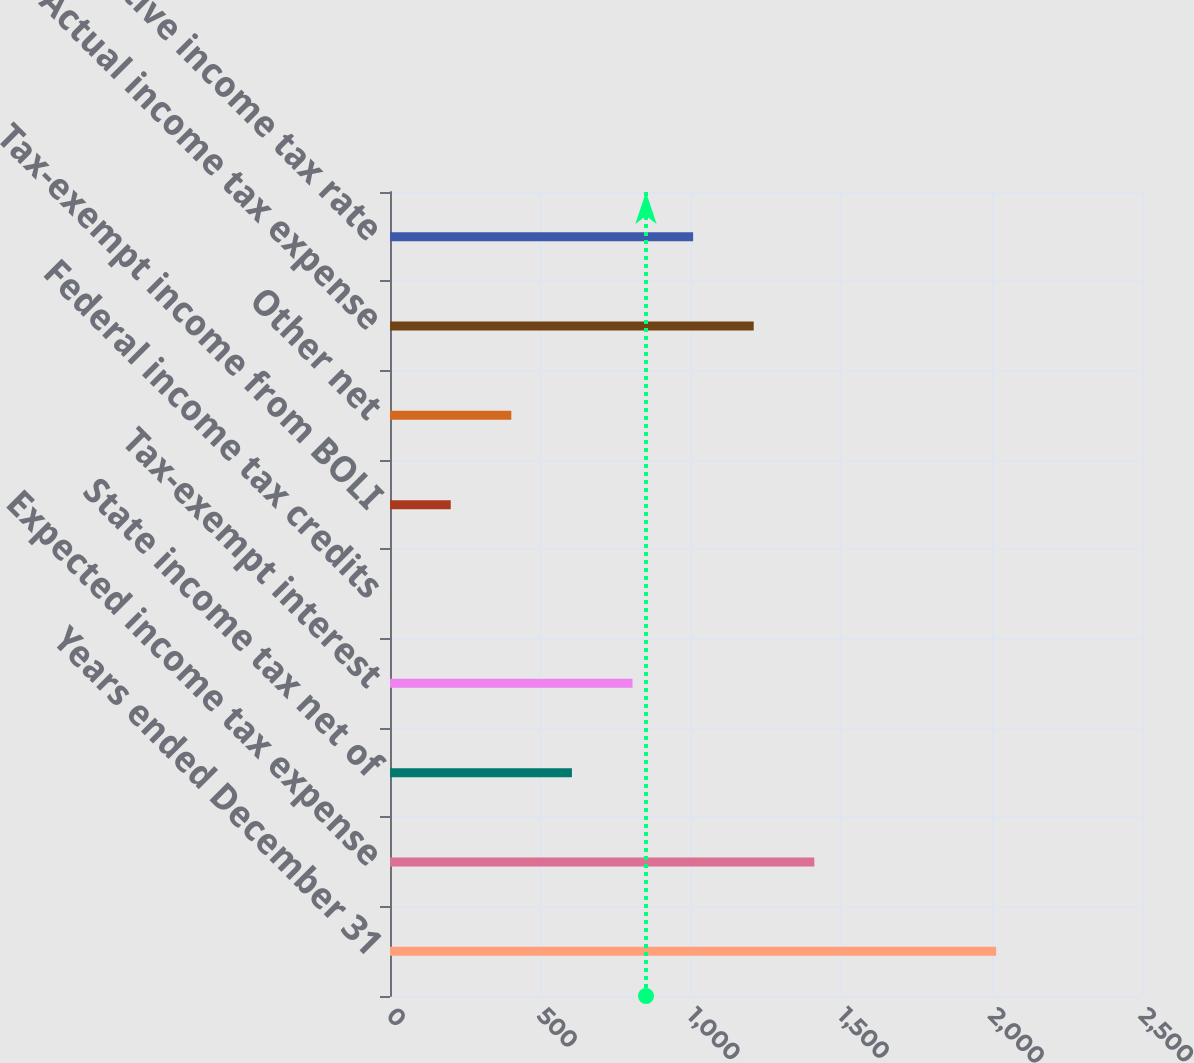Convert chart. <chart><loc_0><loc_0><loc_500><loc_500><bar_chart><fcel>Years ended December 31<fcel>Expected income tax expense<fcel>State income tax net of<fcel>Tax-exempt interest<fcel>Federal income tax credits<fcel>Tax-exempt income from BOLI<fcel>Other net<fcel>Actual income tax expense<fcel>Effective income tax rate<nl><fcel>2015<fcel>1410.62<fcel>604.78<fcel>806.24<fcel>0.4<fcel>201.86<fcel>403.32<fcel>1209.16<fcel>1007.7<nl></chart> 